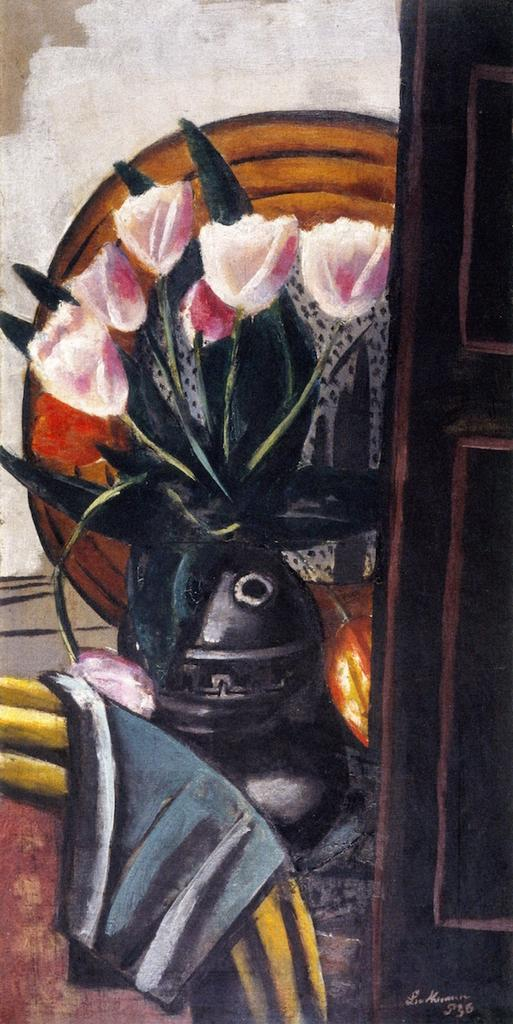What is the main subject of the painting in the image? There is a painting of a decorative plant in the image. What is the unusual element depicted in the painting? There is a flame depicted in the painting. What type of architectural feature can be seen in the image? There is a door in the image. What is the background of the image made of? There is a wall in the image. What else is present in the image besides the painting? There are objects in the image. Is there any text present in the image? Yes, there is text written on the image. How does the substance in the image react to the earthquake? There is no substance or earthquake present in the image; it features a painting of a decorative plant with a flame. What type of blow can be seen being delivered in the image? There is no blow or any indication of physical violence in the image. 